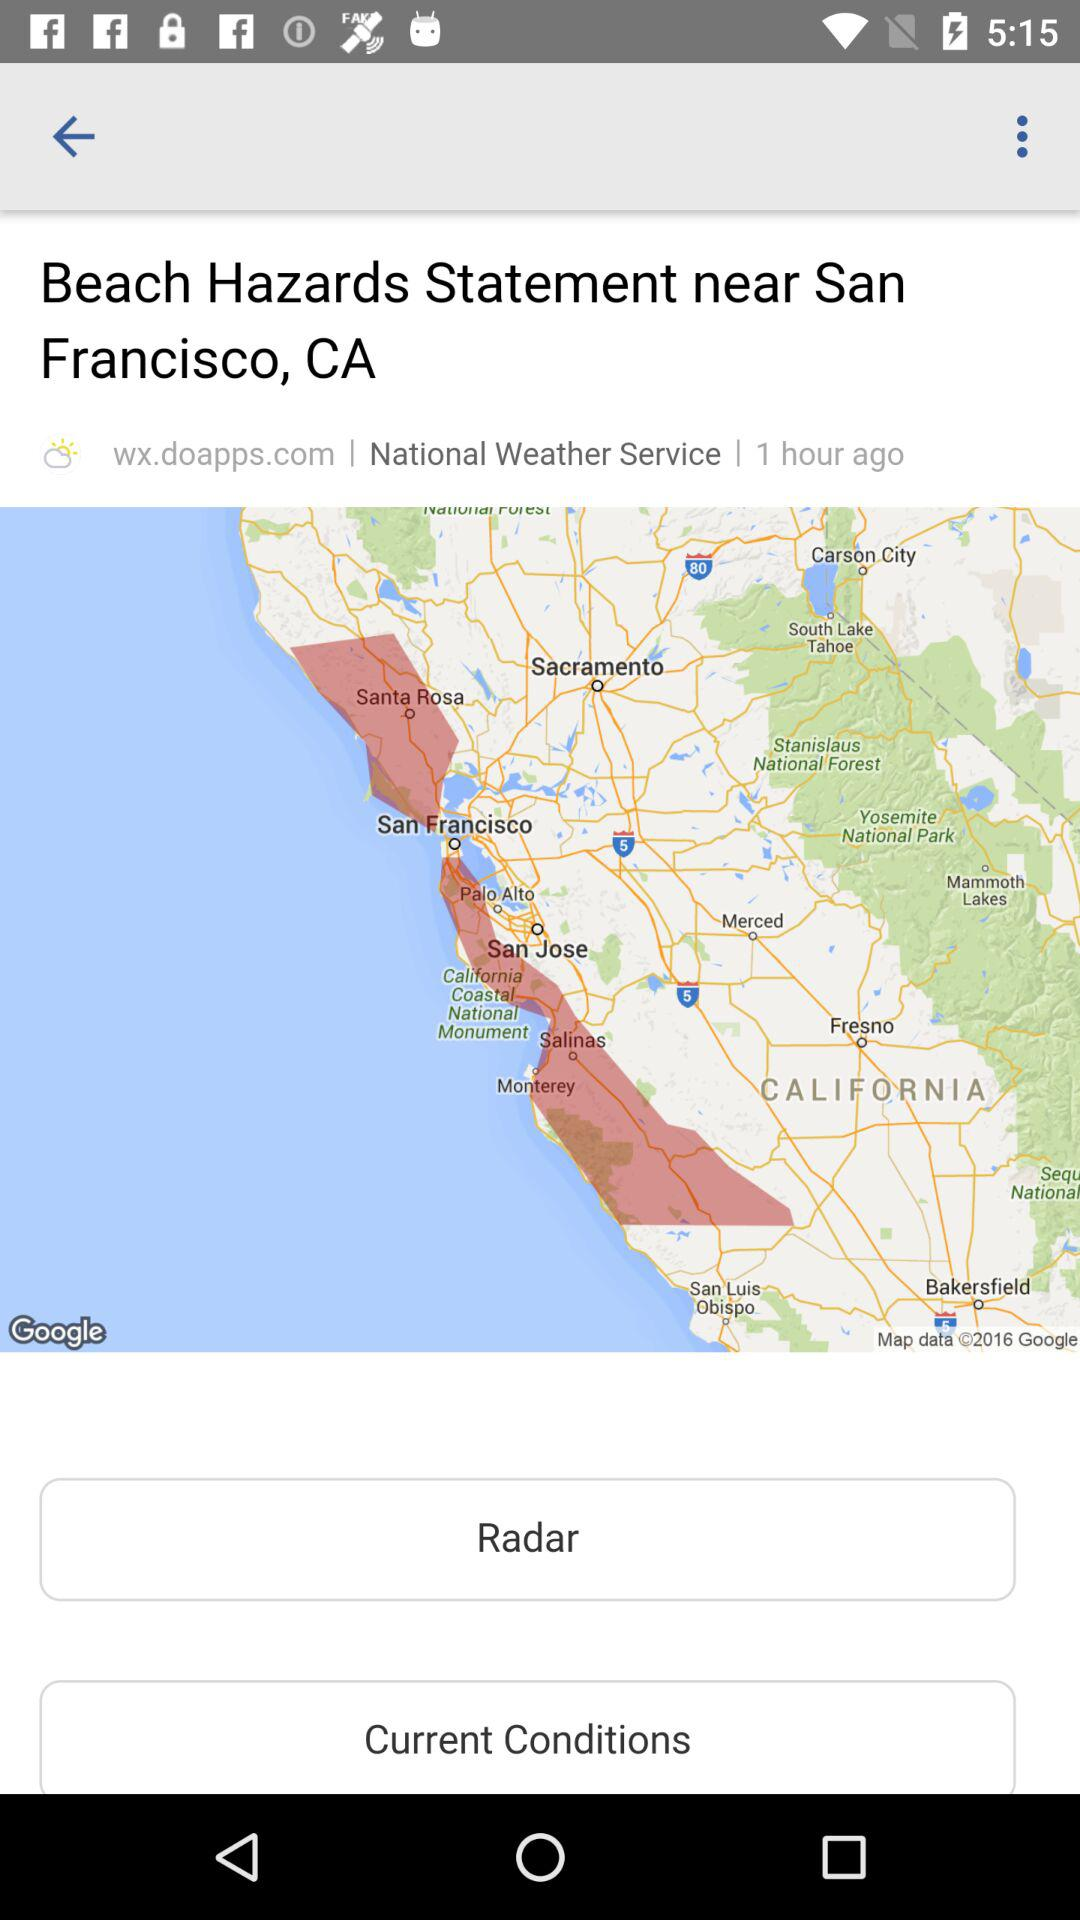How many hours ago was the beach hazards statement issued?
Answer the question using a single word or phrase. 1 